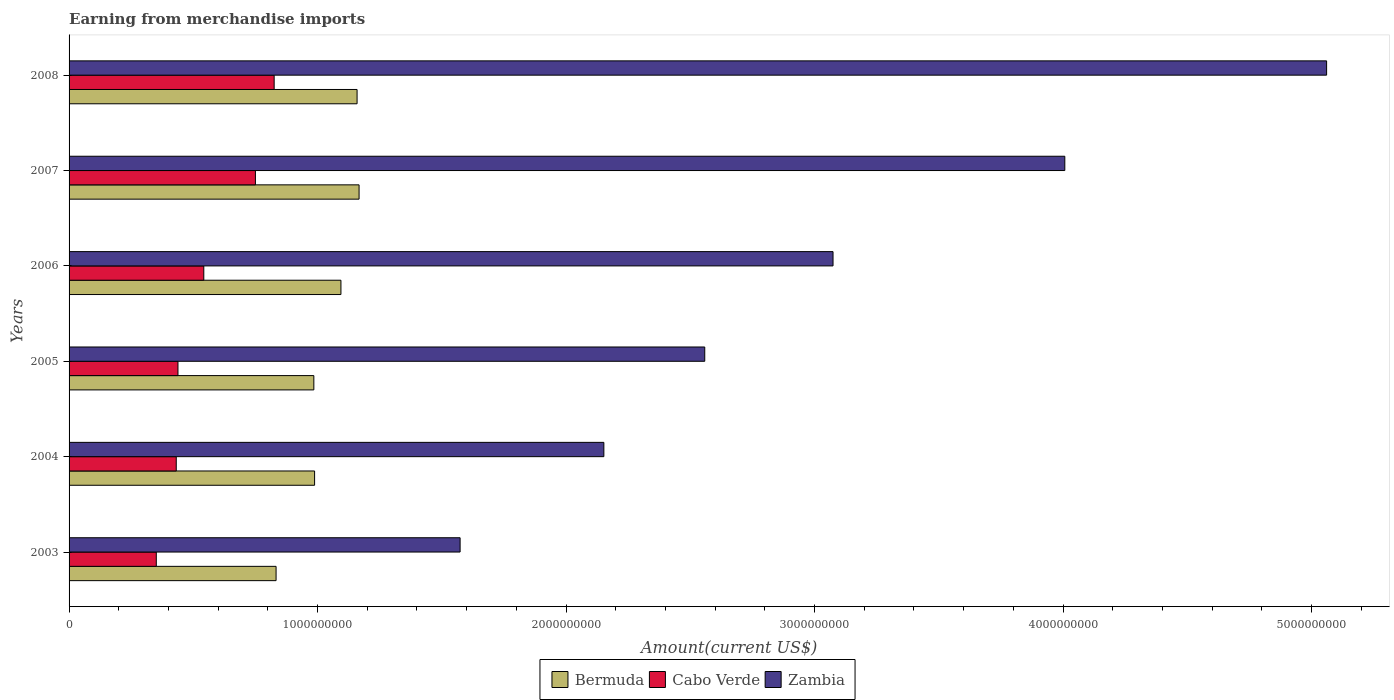How many groups of bars are there?
Offer a very short reply. 6. How many bars are there on the 1st tick from the top?
Give a very brief answer. 3. How many bars are there on the 5th tick from the bottom?
Your answer should be compact. 3. What is the label of the 4th group of bars from the top?
Ensure brevity in your answer.  2005. What is the amount earned from merchandise imports in Cabo Verde in 2004?
Keep it short and to the point. 4.31e+08. Across all years, what is the maximum amount earned from merchandise imports in Bermuda?
Offer a very short reply. 1.17e+09. Across all years, what is the minimum amount earned from merchandise imports in Cabo Verde?
Give a very brief answer. 3.51e+08. In which year was the amount earned from merchandise imports in Bermuda minimum?
Offer a terse response. 2003. What is the total amount earned from merchandise imports in Zambia in the graph?
Your answer should be compact. 1.84e+1. What is the difference between the amount earned from merchandise imports in Bermuda in 2003 and that in 2005?
Give a very brief answer. -1.52e+08. What is the difference between the amount earned from merchandise imports in Bermuda in 2005 and the amount earned from merchandise imports in Cabo Verde in 2003?
Provide a short and direct response. 6.34e+08. What is the average amount earned from merchandise imports in Bermuda per year?
Ensure brevity in your answer.  1.04e+09. In the year 2007, what is the difference between the amount earned from merchandise imports in Bermuda and amount earned from merchandise imports in Zambia?
Your answer should be very brief. -2.84e+09. In how many years, is the amount earned from merchandise imports in Cabo Verde greater than 800000000 US$?
Your response must be concise. 1. What is the ratio of the amount earned from merchandise imports in Cabo Verde in 2003 to that in 2008?
Your answer should be very brief. 0.43. Is the amount earned from merchandise imports in Bermuda in 2003 less than that in 2007?
Provide a succinct answer. Yes. What is the difference between the highest and the second highest amount earned from merchandise imports in Bermuda?
Offer a very short reply. 8.00e+06. What is the difference between the highest and the lowest amount earned from merchandise imports in Bermuda?
Provide a succinct answer. 3.34e+08. Is the sum of the amount earned from merchandise imports in Bermuda in 2005 and 2006 greater than the maximum amount earned from merchandise imports in Cabo Verde across all years?
Your answer should be very brief. Yes. What does the 3rd bar from the top in 2003 represents?
Offer a very short reply. Bermuda. What does the 2nd bar from the bottom in 2005 represents?
Your answer should be very brief. Cabo Verde. Are the values on the major ticks of X-axis written in scientific E-notation?
Offer a very short reply. No. Does the graph contain any zero values?
Your response must be concise. No. Does the graph contain grids?
Offer a very short reply. No. What is the title of the graph?
Keep it short and to the point. Earning from merchandise imports. Does "Albania" appear as one of the legend labels in the graph?
Your response must be concise. No. What is the label or title of the X-axis?
Offer a very short reply. Amount(current US$). What is the label or title of the Y-axis?
Your answer should be compact. Years. What is the Amount(current US$) of Bermuda in 2003?
Make the answer very short. 8.33e+08. What is the Amount(current US$) in Cabo Verde in 2003?
Your answer should be very brief. 3.51e+08. What is the Amount(current US$) in Zambia in 2003?
Your answer should be very brief. 1.57e+09. What is the Amount(current US$) in Bermuda in 2004?
Give a very brief answer. 9.88e+08. What is the Amount(current US$) in Cabo Verde in 2004?
Your answer should be very brief. 4.31e+08. What is the Amount(current US$) in Zambia in 2004?
Your answer should be very brief. 2.15e+09. What is the Amount(current US$) of Bermuda in 2005?
Provide a succinct answer. 9.85e+08. What is the Amount(current US$) in Cabo Verde in 2005?
Provide a short and direct response. 4.38e+08. What is the Amount(current US$) of Zambia in 2005?
Offer a very short reply. 2.56e+09. What is the Amount(current US$) in Bermuda in 2006?
Your answer should be very brief. 1.09e+09. What is the Amount(current US$) in Cabo Verde in 2006?
Provide a succinct answer. 5.42e+08. What is the Amount(current US$) in Zambia in 2006?
Make the answer very short. 3.07e+09. What is the Amount(current US$) in Bermuda in 2007?
Offer a very short reply. 1.17e+09. What is the Amount(current US$) in Cabo Verde in 2007?
Your answer should be very brief. 7.50e+08. What is the Amount(current US$) of Zambia in 2007?
Give a very brief answer. 4.01e+09. What is the Amount(current US$) of Bermuda in 2008?
Offer a terse response. 1.16e+09. What is the Amount(current US$) in Cabo Verde in 2008?
Your response must be concise. 8.25e+08. What is the Amount(current US$) of Zambia in 2008?
Give a very brief answer. 5.06e+09. Across all years, what is the maximum Amount(current US$) in Bermuda?
Make the answer very short. 1.17e+09. Across all years, what is the maximum Amount(current US$) in Cabo Verde?
Keep it short and to the point. 8.25e+08. Across all years, what is the maximum Amount(current US$) of Zambia?
Offer a very short reply. 5.06e+09. Across all years, what is the minimum Amount(current US$) in Bermuda?
Give a very brief answer. 8.33e+08. Across all years, what is the minimum Amount(current US$) in Cabo Verde?
Your answer should be very brief. 3.51e+08. Across all years, what is the minimum Amount(current US$) of Zambia?
Ensure brevity in your answer.  1.57e+09. What is the total Amount(current US$) in Bermuda in the graph?
Give a very brief answer. 6.23e+09. What is the total Amount(current US$) of Cabo Verde in the graph?
Give a very brief answer. 3.34e+09. What is the total Amount(current US$) of Zambia in the graph?
Provide a succinct answer. 1.84e+1. What is the difference between the Amount(current US$) of Bermuda in 2003 and that in 2004?
Your answer should be very brief. -1.55e+08. What is the difference between the Amount(current US$) of Cabo Verde in 2003 and that in 2004?
Your response must be concise. -8.03e+07. What is the difference between the Amount(current US$) in Zambia in 2003 and that in 2004?
Keep it short and to the point. -5.78e+08. What is the difference between the Amount(current US$) of Bermuda in 2003 and that in 2005?
Your response must be concise. -1.52e+08. What is the difference between the Amount(current US$) in Cabo Verde in 2003 and that in 2005?
Ensure brevity in your answer.  -8.72e+07. What is the difference between the Amount(current US$) of Zambia in 2003 and that in 2005?
Make the answer very short. -9.84e+08. What is the difference between the Amount(current US$) of Bermuda in 2003 and that in 2006?
Make the answer very short. -2.61e+08. What is the difference between the Amount(current US$) in Cabo Verde in 2003 and that in 2006?
Provide a short and direct response. -1.91e+08. What is the difference between the Amount(current US$) of Zambia in 2003 and that in 2006?
Offer a very short reply. -1.50e+09. What is the difference between the Amount(current US$) in Bermuda in 2003 and that in 2007?
Keep it short and to the point. -3.34e+08. What is the difference between the Amount(current US$) in Cabo Verde in 2003 and that in 2007?
Your answer should be very brief. -3.99e+08. What is the difference between the Amount(current US$) in Zambia in 2003 and that in 2007?
Your response must be concise. -2.43e+09. What is the difference between the Amount(current US$) of Bermuda in 2003 and that in 2008?
Your answer should be compact. -3.26e+08. What is the difference between the Amount(current US$) in Cabo Verde in 2003 and that in 2008?
Ensure brevity in your answer.  -4.74e+08. What is the difference between the Amount(current US$) of Zambia in 2003 and that in 2008?
Offer a terse response. -3.49e+09. What is the difference between the Amount(current US$) of Bermuda in 2004 and that in 2005?
Make the answer very short. 3.00e+06. What is the difference between the Amount(current US$) in Cabo Verde in 2004 and that in 2005?
Offer a terse response. -6.89e+06. What is the difference between the Amount(current US$) in Zambia in 2004 and that in 2005?
Your response must be concise. -4.06e+08. What is the difference between the Amount(current US$) of Bermuda in 2004 and that in 2006?
Keep it short and to the point. -1.06e+08. What is the difference between the Amount(current US$) in Cabo Verde in 2004 and that in 2006?
Keep it short and to the point. -1.11e+08. What is the difference between the Amount(current US$) in Zambia in 2004 and that in 2006?
Keep it short and to the point. -9.22e+08. What is the difference between the Amount(current US$) in Bermuda in 2004 and that in 2007?
Provide a succinct answer. -1.79e+08. What is the difference between the Amount(current US$) in Cabo Verde in 2004 and that in 2007?
Ensure brevity in your answer.  -3.19e+08. What is the difference between the Amount(current US$) in Zambia in 2004 and that in 2007?
Offer a very short reply. -1.85e+09. What is the difference between the Amount(current US$) of Bermuda in 2004 and that in 2008?
Your answer should be very brief. -1.71e+08. What is the difference between the Amount(current US$) of Cabo Verde in 2004 and that in 2008?
Your answer should be compact. -3.94e+08. What is the difference between the Amount(current US$) in Zambia in 2004 and that in 2008?
Your answer should be very brief. -2.91e+09. What is the difference between the Amount(current US$) of Bermuda in 2005 and that in 2006?
Provide a short and direct response. -1.09e+08. What is the difference between the Amount(current US$) in Cabo Verde in 2005 and that in 2006?
Your answer should be compact. -1.04e+08. What is the difference between the Amount(current US$) in Zambia in 2005 and that in 2006?
Keep it short and to the point. -5.16e+08. What is the difference between the Amount(current US$) of Bermuda in 2005 and that in 2007?
Provide a short and direct response. -1.82e+08. What is the difference between the Amount(current US$) of Cabo Verde in 2005 and that in 2007?
Make the answer very short. -3.12e+08. What is the difference between the Amount(current US$) of Zambia in 2005 and that in 2007?
Your answer should be very brief. -1.45e+09. What is the difference between the Amount(current US$) of Bermuda in 2005 and that in 2008?
Your response must be concise. -1.74e+08. What is the difference between the Amount(current US$) in Cabo Verde in 2005 and that in 2008?
Offer a very short reply. -3.87e+08. What is the difference between the Amount(current US$) of Zambia in 2005 and that in 2008?
Your answer should be very brief. -2.50e+09. What is the difference between the Amount(current US$) of Bermuda in 2006 and that in 2007?
Your answer should be very brief. -7.30e+07. What is the difference between the Amount(current US$) in Cabo Verde in 2006 and that in 2007?
Make the answer very short. -2.08e+08. What is the difference between the Amount(current US$) of Zambia in 2006 and that in 2007?
Make the answer very short. -9.33e+08. What is the difference between the Amount(current US$) in Bermuda in 2006 and that in 2008?
Your response must be concise. -6.50e+07. What is the difference between the Amount(current US$) in Cabo Verde in 2006 and that in 2008?
Your response must be concise. -2.83e+08. What is the difference between the Amount(current US$) of Zambia in 2006 and that in 2008?
Make the answer very short. -1.99e+09. What is the difference between the Amount(current US$) of Bermuda in 2007 and that in 2008?
Your answer should be compact. 8.00e+06. What is the difference between the Amount(current US$) in Cabo Verde in 2007 and that in 2008?
Make the answer very short. -7.54e+07. What is the difference between the Amount(current US$) in Zambia in 2007 and that in 2008?
Your answer should be very brief. -1.05e+09. What is the difference between the Amount(current US$) of Bermuda in 2003 and the Amount(current US$) of Cabo Verde in 2004?
Keep it short and to the point. 4.02e+08. What is the difference between the Amount(current US$) of Bermuda in 2003 and the Amount(current US$) of Zambia in 2004?
Provide a succinct answer. -1.32e+09. What is the difference between the Amount(current US$) of Cabo Verde in 2003 and the Amount(current US$) of Zambia in 2004?
Provide a succinct answer. -1.80e+09. What is the difference between the Amount(current US$) of Bermuda in 2003 and the Amount(current US$) of Cabo Verde in 2005?
Your answer should be very brief. 3.95e+08. What is the difference between the Amount(current US$) in Bermuda in 2003 and the Amount(current US$) in Zambia in 2005?
Your answer should be very brief. -1.73e+09. What is the difference between the Amount(current US$) of Cabo Verde in 2003 and the Amount(current US$) of Zambia in 2005?
Your answer should be very brief. -2.21e+09. What is the difference between the Amount(current US$) in Bermuda in 2003 and the Amount(current US$) in Cabo Verde in 2006?
Provide a succinct answer. 2.91e+08. What is the difference between the Amount(current US$) in Bermuda in 2003 and the Amount(current US$) in Zambia in 2006?
Your answer should be compact. -2.24e+09. What is the difference between the Amount(current US$) of Cabo Verde in 2003 and the Amount(current US$) of Zambia in 2006?
Keep it short and to the point. -2.72e+09. What is the difference between the Amount(current US$) in Bermuda in 2003 and the Amount(current US$) in Cabo Verde in 2007?
Your answer should be compact. 8.31e+07. What is the difference between the Amount(current US$) of Bermuda in 2003 and the Amount(current US$) of Zambia in 2007?
Your answer should be compact. -3.17e+09. What is the difference between the Amount(current US$) in Cabo Verde in 2003 and the Amount(current US$) in Zambia in 2007?
Offer a very short reply. -3.66e+09. What is the difference between the Amount(current US$) of Bermuda in 2003 and the Amount(current US$) of Cabo Verde in 2008?
Your answer should be very brief. 7.70e+06. What is the difference between the Amount(current US$) of Bermuda in 2003 and the Amount(current US$) of Zambia in 2008?
Ensure brevity in your answer.  -4.23e+09. What is the difference between the Amount(current US$) of Cabo Verde in 2003 and the Amount(current US$) of Zambia in 2008?
Ensure brevity in your answer.  -4.71e+09. What is the difference between the Amount(current US$) of Bermuda in 2004 and the Amount(current US$) of Cabo Verde in 2005?
Your response must be concise. 5.50e+08. What is the difference between the Amount(current US$) in Bermuda in 2004 and the Amount(current US$) in Zambia in 2005?
Give a very brief answer. -1.57e+09. What is the difference between the Amount(current US$) in Cabo Verde in 2004 and the Amount(current US$) in Zambia in 2005?
Ensure brevity in your answer.  -2.13e+09. What is the difference between the Amount(current US$) in Bermuda in 2004 and the Amount(current US$) in Cabo Verde in 2006?
Make the answer very short. 4.46e+08. What is the difference between the Amount(current US$) of Bermuda in 2004 and the Amount(current US$) of Zambia in 2006?
Keep it short and to the point. -2.09e+09. What is the difference between the Amount(current US$) in Cabo Verde in 2004 and the Amount(current US$) in Zambia in 2006?
Ensure brevity in your answer.  -2.64e+09. What is the difference between the Amount(current US$) of Bermuda in 2004 and the Amount(current US$) of Cabo Verde in 2007?
Give a very brief answer. 2.38e+08. What is the difference between the Amount(current US$) in Bermuda in 2004 and the Amount(current US$) in Zambia in 2007?
Provide a short and direct response. -3.02e+09. What is the difference between the Amount(current US$) in Cabo Verde in 2004 and the Amount(current US$) in Zambia in 2007?
Offer a very short reply. -3.58e+09. What is the difference between the Amount(current US$) in Bermuda in 2004 and the Amount(current US$) in Cabo Verde in 2008?
Ensure brevity in your answer.  1.63e+08. What is the difference between the Amount(current US$) in Bermuda in 2004 and the Amount(current US$) in Zambia in 2008?
Your answer should be compact. -4.07e+09. What is the difference between the Amount(current US$) in Cabo Verde in 2004 and the Amount(current US$) in Zambia in 2008?
Offer a terse response. -4.63e+09. What is the difference between the Amount(current US$) in Bermuda in 2005 and the Amount(current US$) in Cabo Verde in 2006?
Keep it short and to the point. 4.43e+08. What is the difference between the Amount(current US$) of Bermuda in 2005 and the Amount(current US$) of Zambia in 2006?
Keep it short and to the point. -2.09e+09. What is the difference between the Amount(current US$) of Cabo Verde in 2005 and the Amount(current US$) of Zambia in 2006?
Your answer should be very brief. -2.64e+09. What is the difference between the Amount(current US$) of Bermuda in 2005 and the Amount(current US$) of Cabo Verde in 2007?
Offer a terse response. 2.35e+08. What is the difference between the Amount(current US$) in Bermuda in 2005 and the Amount(current US$) in Zambia in 2007?
Provide a succinct answer. -3.02e+09. What is the difference between the Amount(current US$) of Cabo Verde in 2005 and the Amount(current US$) of Zambia in 2007?
Give a very brief answer. -3.57e+09. What is the difference between the Amount(current US$) in Bermuda in 2005 and the Amount(current US$) in Cabo Verde in 2008?
Make the answer very short. 1.60e+08. What is the difference between the Amount(current US$) of Bermuda in 2005 and the Amount(current US$) of Zambia in 2008?
Your answer should be very brief. -4.08e+09. What is the difference between the Amount(current US$) in Cabo Verde in 2005 and the Amount(current US$) in Zambia in 2008?
Ensure brevity in your answer.  -4.62e+09. What is the difference between the Amount(current US$) of Bermuda in 2006 and the Amount(current US$) of Cabo Verde in 2007?
Provide a short and direct response. 3.44e+08. What is the difference between the Amount(current US$) in Bermuda in 2006 and the Amount(current US$) in Zambia in 2007?
Your response must be concise. -2.91e+09. What is the difference between the Amount(current US$) of Cabo Verde in 2006 and the Amount(current US$) of Zambia in 2007?
Ensure brevity in your answer.  -3.46e+09. What is the difference between the Amount(current US$) of Bermuda in 2006 and the Amount(current US$) of Cabo Verde in 2008?
Your answer should be very brief. 2.69e+08. What is the difference between the Amount(current US$) in Bermuda in 2006 and the Amount(current US$) in Zambia in 2008?
Your answer should be very brief. -3.97e+09. What is the difference between the Amount(current US$) in Cabo Verde in 2006 and the Amount(current US$) in Zambia in 2008?
Your answer should be compact. -4.52e+09. What is the difference between the Amount(current US$) of Bermuda in 2007 and the Amount(current US$) of Cabo Verde in 2008?
Provide a succinct answer. 3.42e+08. What is the difference between the Amount(current US$) in Bermuda in 2007 and the Amount(current US$) in Zambia in 2008?
Offer a terse response. -3.89e+09. What is the difference between the Amount(current US$) of Cabo Verde in 2007 and the Amount(current US$) of Zambia in 2008?
Provide a succinct answer. -4.31e+09. What is the average Amount(current US$) of Bermuda per year?
Offer a very short reply. 1.04e+09. What is the average Amount(current US$) of Cabo Verde per year?
Provide a succinct answer. 5.56e+08. What is the average Amount(current US$) of Zambia per year?
Give a very brief answer. 3.07e+09. In the year 2003, what is the difference between the Amount(current US$) in Bermuda and Amount(current US$) in Cabo Verde?
Keep it short and to the point. 4.82e+08. In the year 2003, what is the difference between the Amount(current US$) in Bermuda and Amount(current US$) in Zambia?
Your answer should be very brief. -7.41e+08. In the year 2003, what is the difference between the Amount(current US$) in Cabo Verde and Amount(current US$) in Zambia?
Offer a very short reply. -1.22e+09. In the year 2004, what is the difference between the Amount(current US$) in Bermuda and Amount(current US$) in Cabo Verde?
Provide a succinct answer. 5.57e+08. In the year 2004, what is the difference between the Amount(current US$) of Bermuda and Amount(current US$) of Zambia?
Your response must be concise. -1.16e+09. In the year 2004, what is the difference between the Amount(current US$) in Cabo Verde and Amount(current US$) in Zambia?
Provide a succinct answer. -1.72e+09. In the year 2005, what is the difference between the Amount(current US$) of Bermuda and Amount(current US$) of Cabo Verde?
Your answer should be compact. 5.47e+08. In the year 2005, what is the difference between the Amount(current US$) in Bermuda and Amount(current US$) in Zambia?
Give a very brief answer. -1.57e+09. In the year 2005, what is the difference between the Amount(current US$) of Cabo Verde and Amount(current US$) of Zambia?
Offer a very short reply. -2.12e+09. In the year 2006, what is the difference between the Amount(current US$) in Bermuda and Amount(current US$) in Cabo Verde?
Ensure brevity in your answer.  5.52e+08. In the year 2006, what is the difference between the Amount(current US$) in Bermuda and Amount(current US$) in Zambia?
Give a very brief answer. -1.98e+09. In the year 2006, what is the difference between the Amount(current US$) of Cabo Verde and Amount(current US$) of Zambia?
Provide a short and direct response. -2.53e+09. In the year 2007, what is the difference between the Amount(current US$) in Bermuda and Amount(current US$) in Cabo Verde?
Provide a short and direct response. 4.17e+08. In the year 2007, what is the difference between the Amount(current US$) of Bermuda and Amount(current US$) of Zambia?
Offer a very short reply. -2.84e+09. In the year 2007, what is the difference between the Amount(current US$) of Cabo Verde and Amount(current US$) of Zambia?
Provide a short and direct response. -3.26e+09. In the year 2008, what is the difference between the Amount(current US$) of Bermuda and Amount(current US$) of Cabo Verde?
Your response must be concise. 3.34e+08. In the year 2008, what is the difference between the Amount(current US$) of Bermuda and Amount(current US$) of Zambia?
Your answer should be very brief. -3.90e+09. In the year 2008, what is the difference between the Amount(current US$) of Cabo Verde and Amount(current US$) of Zambia?
Keep it short and to the point. -4.24e+09. What is the ratio of the Amount(current US$) of Bermuda in 2003 to that in 2004?
Your answer should be very brief. 0.84. What is the ratio of the Amount(current US$) in Cabo Verde in 2003 to that in 2004?
Give a very brief answer. 0.81. What is the ratio of the Amount(current US$) of Zambia in 2003 to that in 2004?
Ensure brevity in your answer.  0.73. What is the ratio of the Amount(current US$) of Bermuda in 2003 to that in 2005?
Your answer should be compact. 0.85. What is the ratio of the Amount(current US$) of Cabo Verde in 2003 to that in 2005?
Your answer should be very brief. 0.8. What is the ratio of the Amount(current US$) in Zambia in 2003 to that in 2005?
Provide a short and direct response. 0.62. What is the ratio of the Amount(current US$) in Bermuda in 2003 to that in 2006?
Your response must be concise. 0.76. What is the ratio of the Amount(current US$) of Cabo Verde in 2003 to that in 2006?
Keep it short and to the point. 0.65. What is the ratio of the Amount(current US$) in Zambia in 2003 to that in 2006?
Keep it short and to the point. 0.51. What is the ratio of the Amount(current US$) in Bermuda in 2003 to that in 2007?
Offer a very short reply. 0.71. What is the ratio of the Amount(current US$) of Cabo Verde in 2003 to that in 2007?
Give a very brief answer. 0.47. What is the ratio of the Amount(current US$) in Zambia in 2003 to that in 2007?
Provide a short and direct response. 0.39. What is the ratio of the Amount(current US$) in Bermuda in 2003 to that in 2008?
Make the answer very short. 0.72. What is the ratio of the Amount(current US$) in Cabo Verde in 2003 to that in 2008?
Ensure brevity in your answer.  0.43. What is the ratio of the Amount(current US$) of Zambia in 2003 to that in 2008?
Offer a terse response. 0.31. What is the ratio of the Amount(current US$) in Bermuda in 2004 to that in 2005?
Keep it short and to the point. 1. What is the ratio of the Amount(current US$) of Cabo Verde in 2004 to that in 2005?
Your answer should be compact. 0.98. What is the ratio of the Amount(current US$) in Zambia in 2004 to that in 2005?
Make the answer very short. 0.84. What is the ratio of the Amount(current US$) in Bermuda in 2004 to that in 2006?
Ensure brevity in your answer.  0.9. What is the ratio of the Amount(current US$) in Cabo Verde in 2004 to that in 2006?
Give a very brief answer. 0.8. What is the ratio of the Amount(current US$) of Bermuda in 2004 to that in 2007?
Provide a short and direct response. 0.85. What is the ratio of the Amount(current US$) in Cabo Verde in 2004 to that in 2007?
Your response must be concise. 0.58. What is the ratio of the Amount(current US$) in Zambia in 2004 to that in 2007?
Keep it short and to the point. 0.54. What is the ratio of the Amount(current US$) in Bermuda in 2004 to that in 2008?
Make the answer very short. 0.85. What is the ratio of the Amount(current US$) in Cabo Verde in 2004 to that in 2008?
Ensure brevity in your answer.  0.52. What is the ratio of the Amount(current US$) of Zambia in 2004 to that in 2008?
Offer a very short reply. 0.43. What is the ratio of the Amount(current US$) of Bermuda in 2005 to that in 2006?
Your response must be concise. 0.9. What is the ratio of the Amount(current US$) in Cabo Verde in 2005 to that in 2006?
Ensure brevity in your answer.  0.81. What is the ratio of the Amount(current US$) in Zambia in 2005 to that in 2006?
Give a very brief answer. 0.83. What is the ratio of the Amount(current US$) of Bermuda in 2005 to that in 2007?
Make the answer very short. 0.84. What is the ratio of the Amount(current US$) in Cabo Verde in 2005 to that in 2007?
Provide a short and direct response. 0.58. What is the ratio of the Amount(current US$) in Zambia in 2005 to that in 2007?
Provide a succinct answer. 0.64. What is the ratio of the Amount(current US$) of Bermuda in 2005 to that in 2008?
Your answer should be very brief. 0.85. What is the ratio of the Amount(current US$) in Cabo Verde in 2005 to that in 2008?
Keep it short and to the point. 0.53. What is the ratio of the Amount(current US$) of Zambia in 2005 to that in 2008?
Your answer should be compact. 0.51. What is the ratio of the Amount(current US$) in Bermuda in 2006 to that in 2007?
Ensure brevity in your answer.  0.94. What is the ratio of the Amount(current US$) of Cabo Verde in 2006 to that in 2007?
Offer a terse response. 0.72. What is the ratio of the Amount(current US$) of Zambia in 2006 to that in 2007?
Ensure brevity in your answer.  0.77. What is the ratio of the Amount(current US$) in Bermuda in 2006 to that in 2008?
Offer a terse response. 0.94. What is the ratio of the Amount(current US$) in Cabo Verde in 2006 to that in 2008?
Provide a short and direct response. 0.66. What is the ratio of the Amount(current US$) in Zambia in 2006 to that in 2008?
Offer a terse response. 0.61. What is the ratio of the Amount(current US$) in Cabo Verde in 2007 to that in 2008?
Provide a short and direct response. 0.91. What is the ratio of the Amount(current US$) in Zambia in 2007 to that in 2008?
Offer a terse response. 0.79. What is the difference between the highest and the second highest Amount(current US$) in Cabo Verde?
Keep it short and to the point. 7.54e+07. What is the difference between the highest and the second highest Amount(current US$) in Zambia?
Your answer should be very brief. 1.05e+09. What is the difference between the highest and the lowest Amount(current US$) of Bermuda?
Your response must be concise. 3.34e+08. What is the difference between the highest and the lowest Amount(current US$) in Cabo Verde?
Provide a short and direct response. 4.74e+08. What is the difference between the highest and the lowest Amount(current US$) of Zambia?
Your answer should be compact. 3.49e+09. 